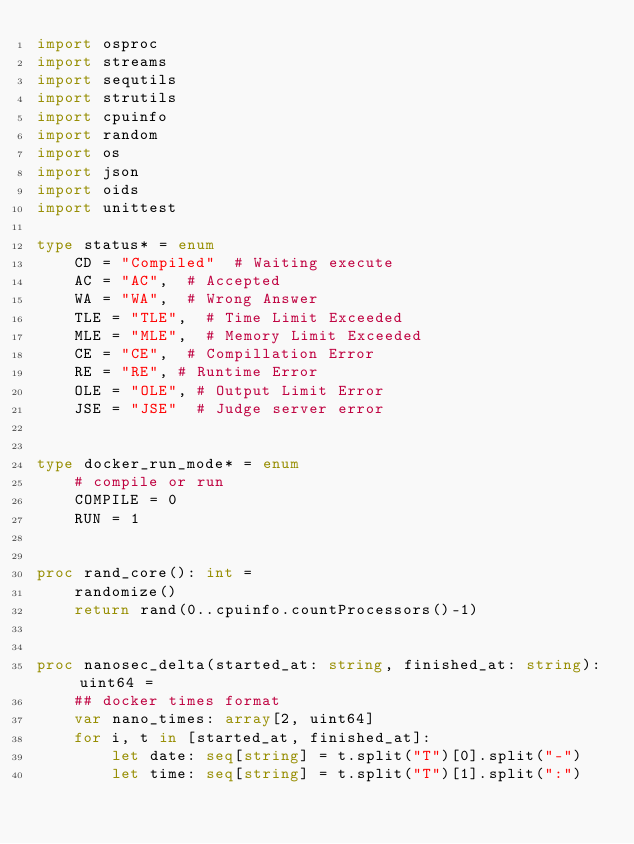Convert code to text. <code><loc_0><loc_0><loc_500><loc_500><_Nim_>import osproc
import streams
import sequtils
import strutils
import cpuinfo
import random
import os
import json
import oids
import unittest

type status* = enum
    CD = "Compiled"  # Waiting execute
    AC = "AC",  # Accepted
    WA = "WA",  # Wrong Answer
    TLE = "TLE",  # Time Limit Exceeded
    MLE = "MLE",  # Memory Limit Exceeded
    CE = "CE",  # Compillation Error
    RE = "RE", # Runtime Error
    OLE = "OLE", # Output Limit Error
    JSE = "JSE"  # Judge server error


type docker_run_mode* = enum
    # compile or run
    COMPILE = 0
    RUN = 1


proc rand_core(): int =
    randomize()
    return rand(0..cpuinfo.countProcessors()-1)


proc nanosec_delta(started_at: string, finished_at: string): uint64 =
    ## docker times format
    var nano_times: array[2, uint64]
    for i, t in [started_at, finished_at]:
        let date: seq[string] = t.split("T")[0].split("-")
        let time: seq[string] = t.split("T")[1].split(":")</code> 